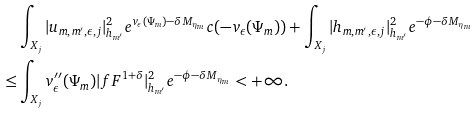<formula> <loc_0><loc_0><loc_500><loc_500>& \int _ { X _ { j } } | u _ { m , m ^ { \prime } , \epsilon , j } | ^ { 2 } _ { h _ { m ^ { \prime } } } e ^ { v _ { \epsilon } ( \Psi _ { m } ) - \delta M _ { \eta _ { m } } } c ( - v _ { \epsilon } ( \Psi _ { m } ) ) + \int _ { X _ { j } } | h _ { m , m ^ { \prime } , \epsilon , j } | ^ { 2 } _ { h _ { m ^ { \prime } } } e ^ { - \phi - \delta M _ { \eta _ { m } } } \\ \leq & \int _ { X _ { j } } v ^ { \prime \prime } _ { \epsilon } ( \Psi _ { m } ) | f F ^ { 1 + \delta } | ^ { 2 } _ { h _ { m ^ { \prime } } } e ^ { - \phi - \delta M _ { \eta _ { m } } } < + \infty .</formula> 